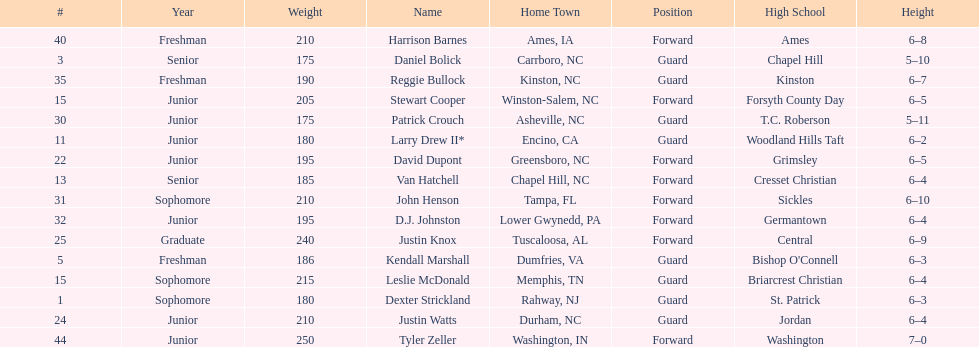Who was taller, justin knox or john henson? John Henson. 